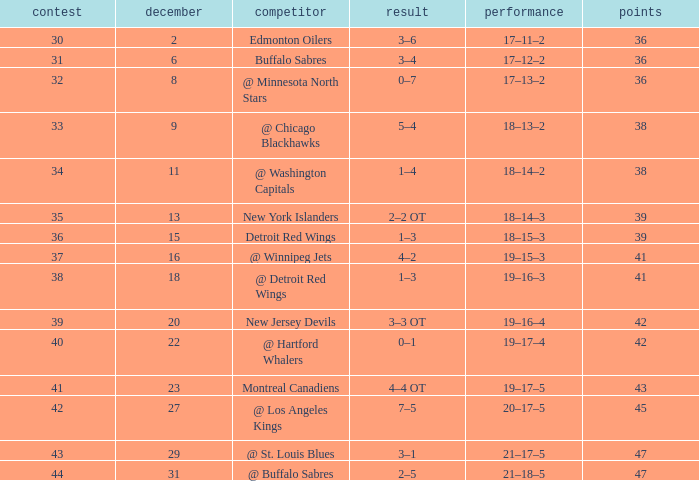After december 29 what is the score? 2–5. 